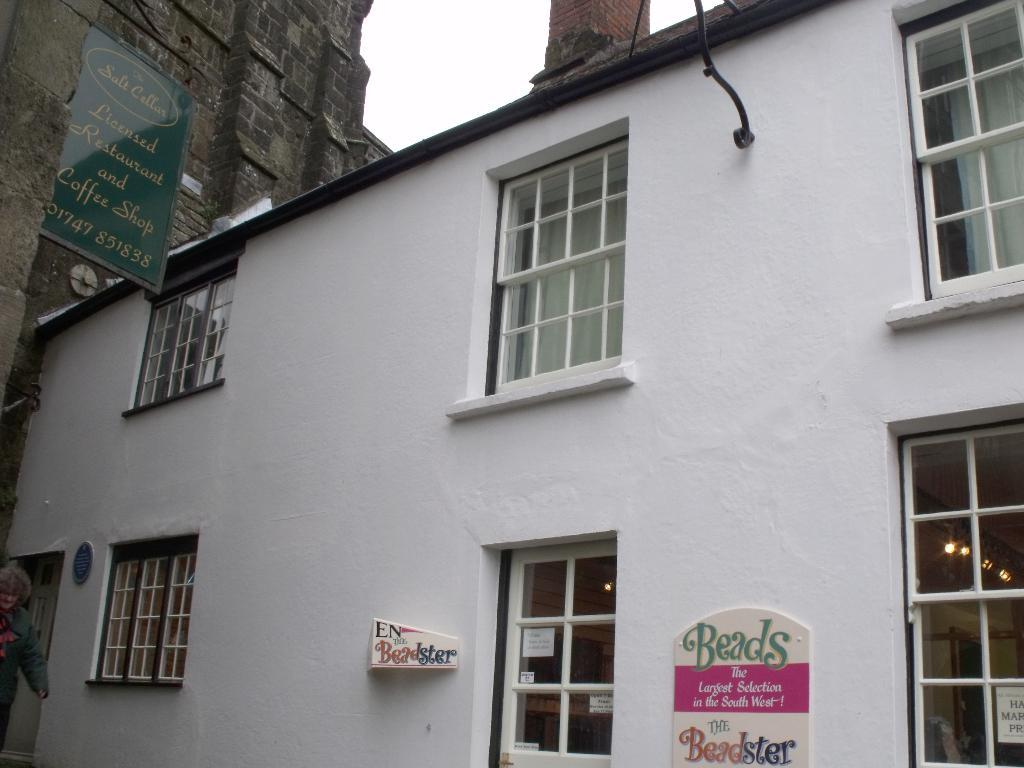What type of structures can be seen in the image? There are buildings in the image. What feature is common among the buildings? The buildings have many windows on their walls. Can you describe the person visible in the image? There is a person visible on the left side of the image. What type of insurance policy does the person on the left side of the image have? There is no information about insurance policies in the image, as it only features buildings and a person. 